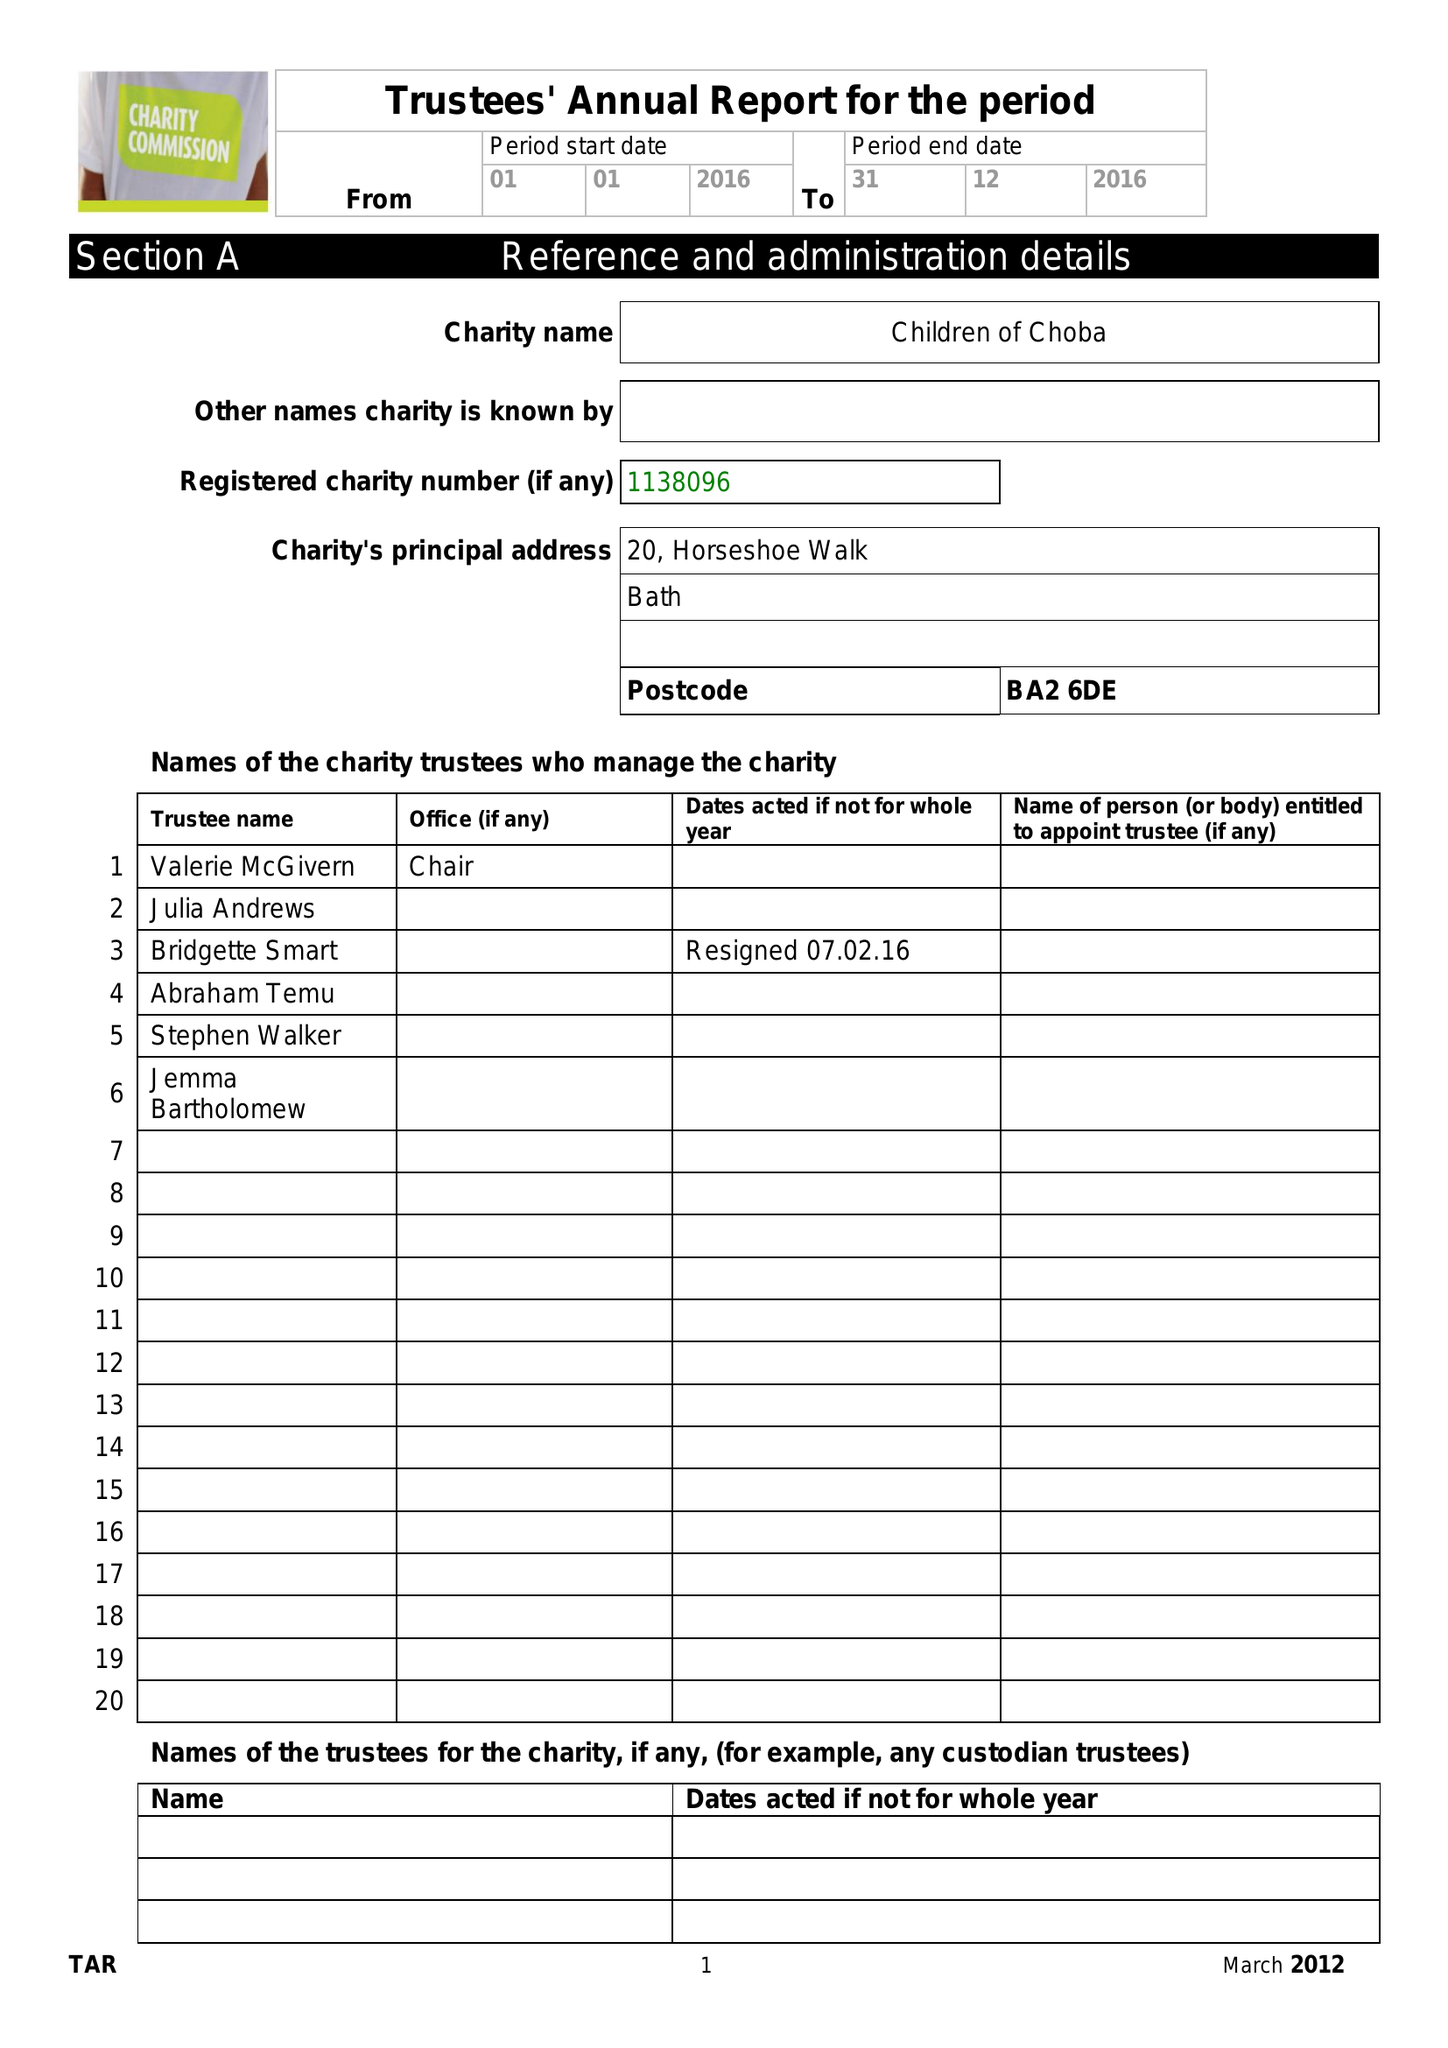What is the value for the spending_annually_in_british_pounds?
Answer the question using a single word or phrase. 48790.00 